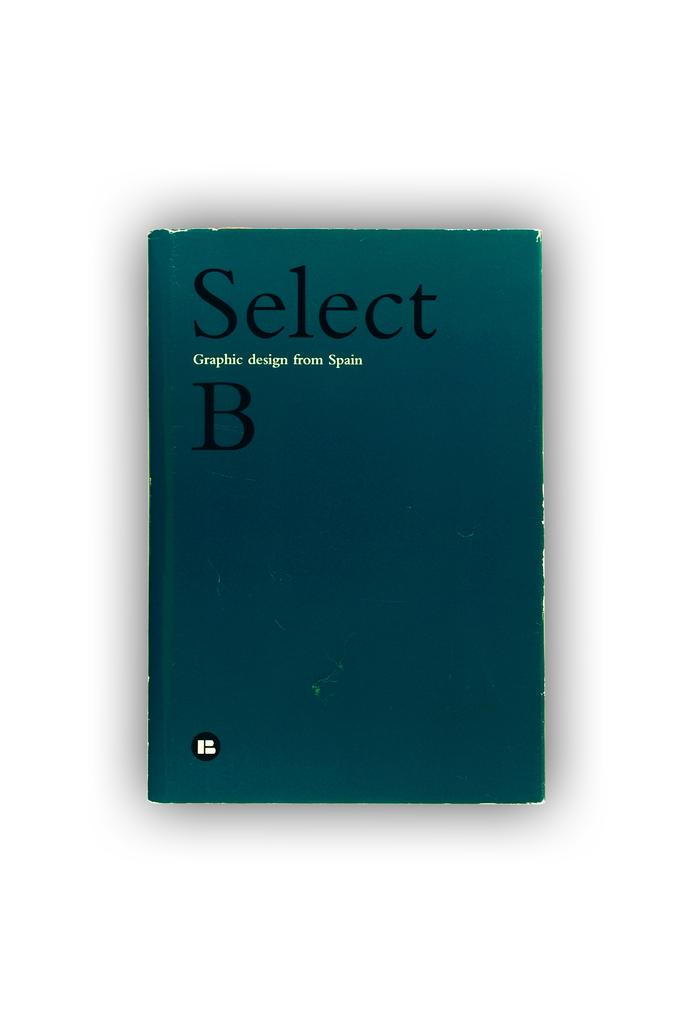<image>
Relay a brief, clear account of the picture shown. A book with a blue cover titled Select Graphic design from Spain B. 